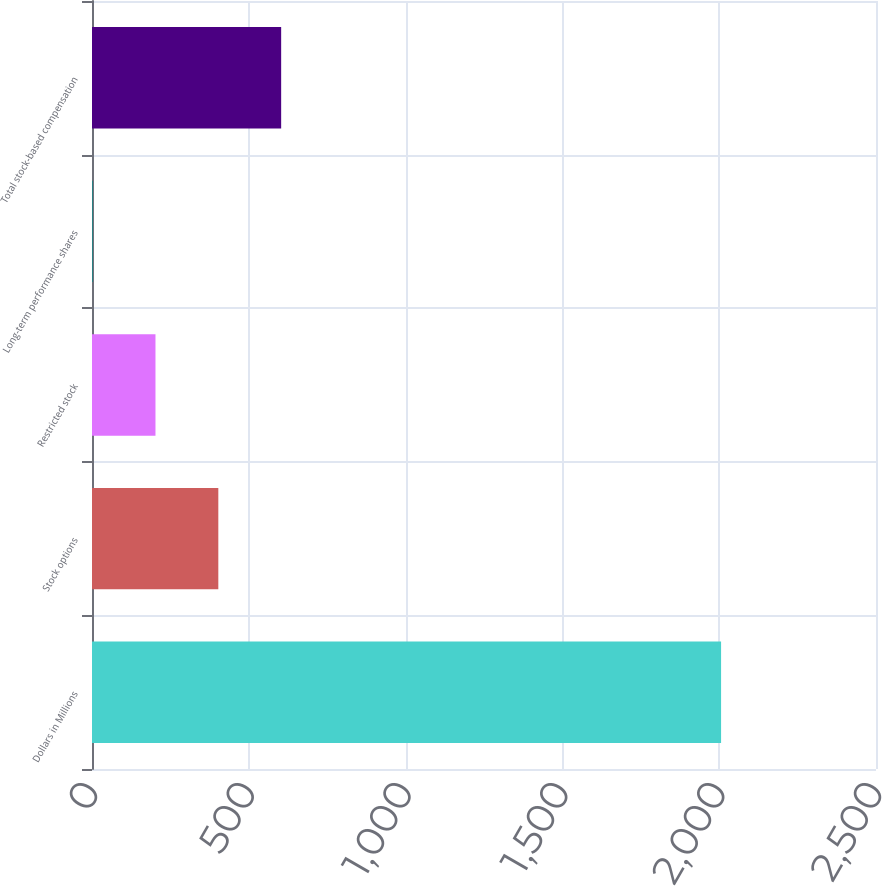Convert chart to OTSL. <chart><loc_0><loc_0><loc_500><loc_500><bar_chart><fcel>Dollars in Millions<fcel>Stock options<fcel>Restricted stock<fcel>Long-term performance shares<fcel>Total stock-based compensation<nl><fcel>2006<fcel>402.8<fcel>202.4<fcel>2<fcel>603.2<nl></chart> 